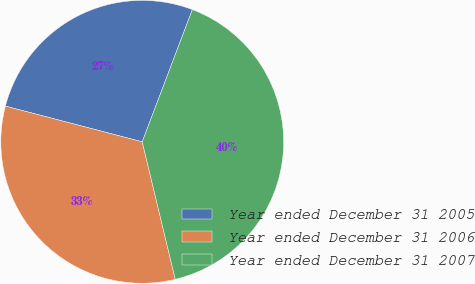<chart> <loc_0><loc_0><loc_500><loc_500><pie_chart><fcel>Year ended December 31 2005<fcel>Year ended December 31 2006<fcel>Year ended December 31 2007<nl><fcel>26.71%<fcel>32.82%<fcel>40.48%<nl></chart> 